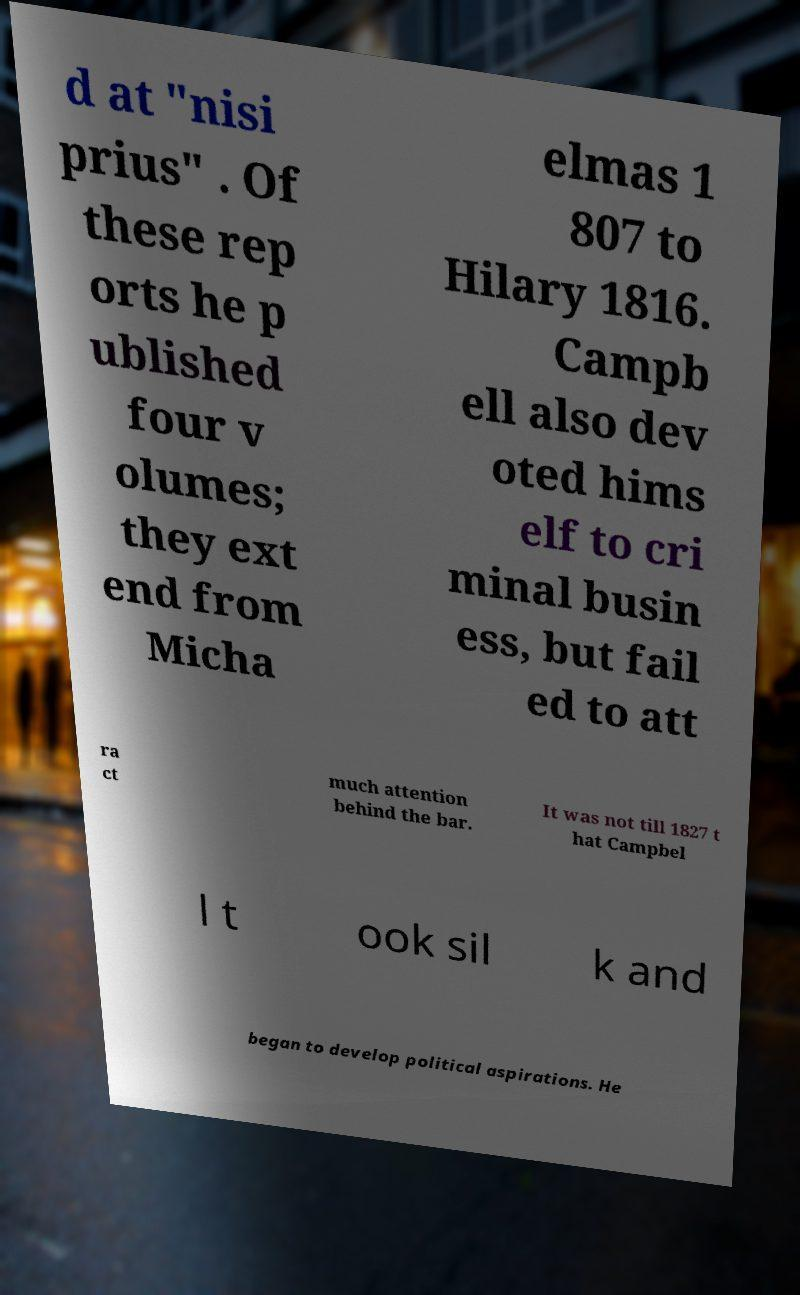Could you assist in decoding the text presented in this image and type it out clearly? d at "nisi prius" . Of these rep orts he p ublished four v olumes; they ext end from Micha elmas 1 807 to Hilary 1816. Campb ell also dev oted hims elf to cri minal busin ess, but fail ed to att ra ct much attention behind the bar. It was not till 1827 t hat Campbel l t ook sil k and began to develop political aspirations. He 